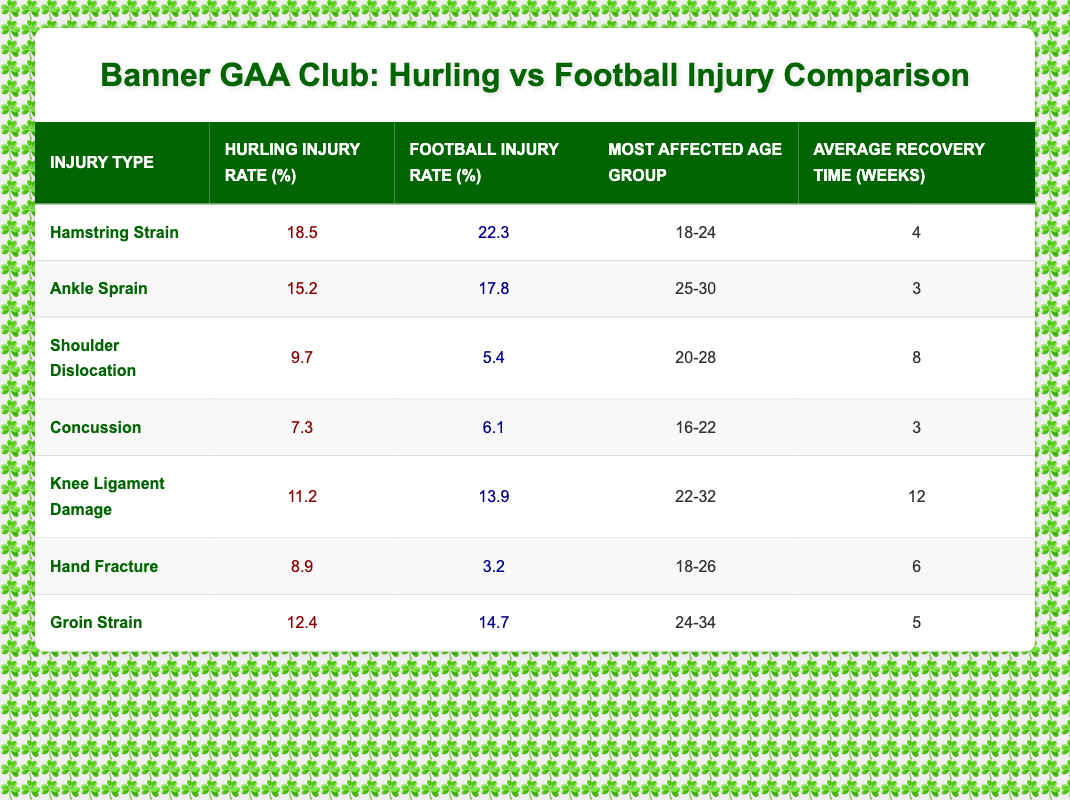What is the injury rate for hamstring strain in hurling? The table shows that the injury rate for hamstring strain in hurling is 18.5%.
Answer: 18.5% Which age group is most affected by shoulder dislocation injuries in hurling? The table indicates that the most affected age group for shoulder dislocation in hurling is 20-28.
Answer: 20-28 Is the football injury rate for knee ligament damage higher than that for hurling? According to the table, the injury rate for knee ligament damage in football is 13.9%, which is higher than the 11.2% for hurling.
Answer: Yes What is the average recovery time for ankle sprains in both sports? The average recovery time for ankle sprains in hurling is 3 weeks and in football is also 3 weeks, therefore the average overall is 3 weeks.
Answer: 3 weeks Which type of injury has the highest percentage in football? By reviewing the football injury rates in the table, the highest percentage is for hamstring strain at 22.3%.
Answer: Hamstring strain What is the difference in injury rates for hand fractures between hurling and football? The injury rate for hand fractures in hurling is 8.9% while in football it is 3.2%. The difference is calculated as 8.9 - 3.2 = 5.7%.
Answer: 5.7% Which sport has a higher injury rate for concussions? The table shows that the injury rate for concussions in hurling is 7.3%, which is higher than 6.1% in football.
Answer: Hurling What is the average injury rate for groin strains in both sports? The injury rate for groin strain in hurling is 12.4% and 14.7% in football. The average injury rate is calculated as (12.4 + 14.7) / 2 = 13.55%.
Answer: 13.55% Are the injury rates for hand fractures significantly different between hurling and football? The table shows an injury rate of 8.9% for hurling and 3.2% for football. While there is a difference, whether it is considered 'significant' can be subjective, though a difference of 5.7% suggests a notable variation.
Answer: Yes 